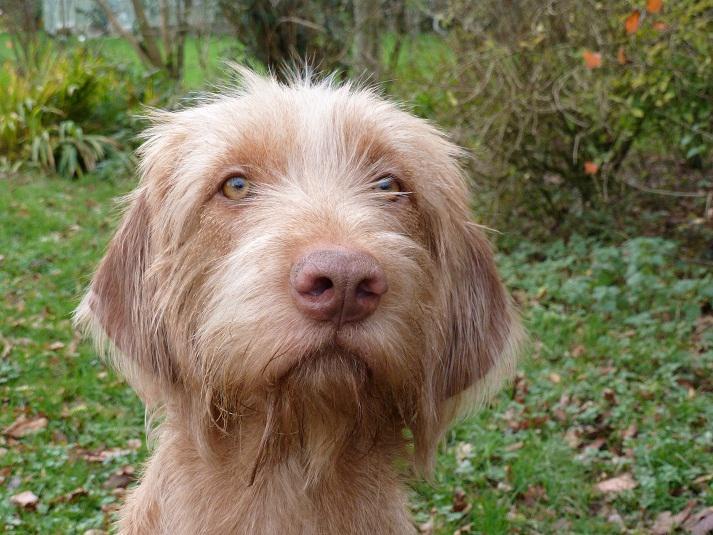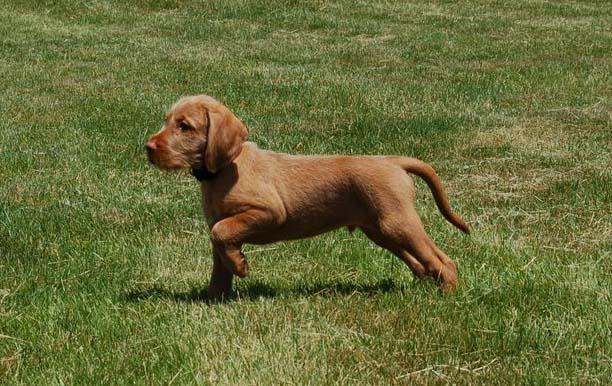The first image is the image on the left, the second image is the image on the right. Evaluate the accuracy of this statement regarding the images: "In one image, a dog is standing with one of its paws lifted up off the ground.". Is it true? Answer yes or no. Yes. 